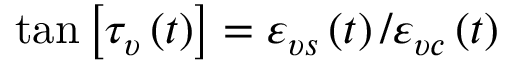<formula> <loc_0><loc_0><loc_500><loc_500>\tan \left [ \tau _ { \upsilon } \left ( t \right ) \right ] = \varepsilon _ { \upsilon s } \left ( t \right ) / \varepsilon _ { \upsilon c } \left ( t \right )</formula> 